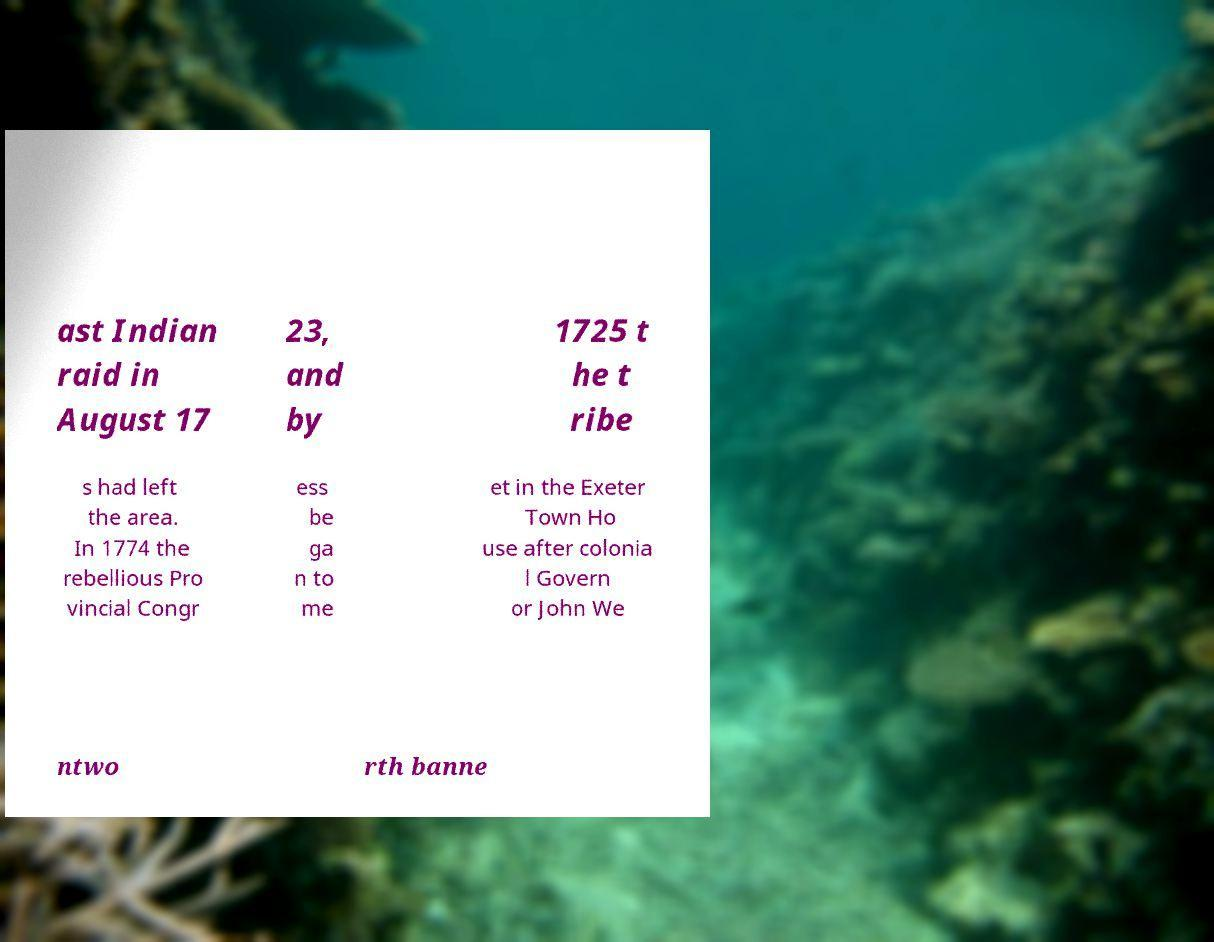I need the written content from this picture converted into text. Can you do that? ast Indian raid in August 17 23, and by 1725 t he t ribe s had left the area. In 1774 the rebellious Pro vincial Congr ess be ga n to me et in the Exeter Town Ho use after colonia l Govern or John We ntwo rth banne 